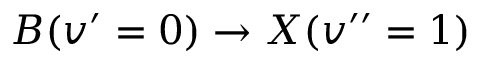<formula> <loc_0><loc_0><loc_500><loc_500>B ( v ^ { \prime } = 0 ) \rightarrow X ( v ^ { \prime \prime } = 1 )</formula> 